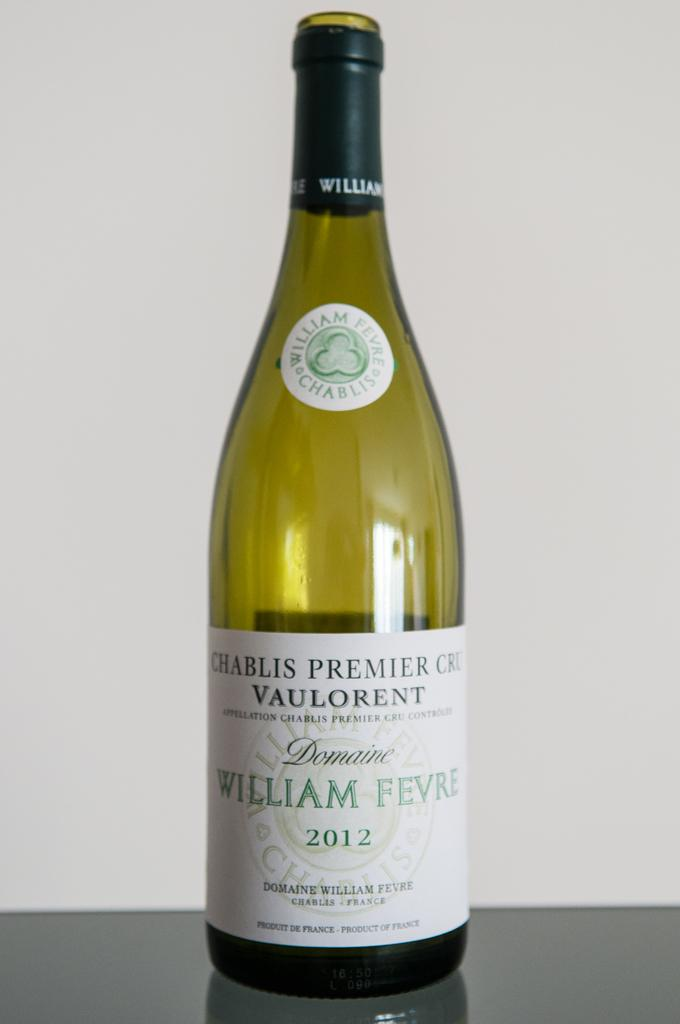What color is the wine bottle in the image? The wine bottle is green. Where is the wine bottle located in the image? The wine bottle is on the floor. What is written on the wine bottle? "William Fevre" is written on the wine bottle. What color is the background of the image? The background of the image is white. Can you describe the texture of the crow in the image? There is no crow present in the image, so it is not possible to describe its texture. 